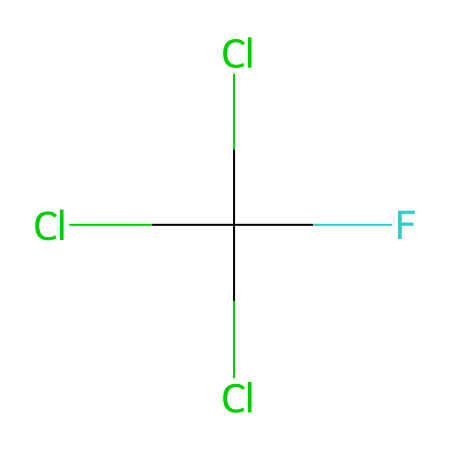What is the total number of halogen atoms in this molecule? The chemical structure shows three chlorine atoms (Cl) and one fluorine atom (F), making a total of four halogen atoms present in this compound.
Answer: four How many carbon atoms are in this chemical? The SMILES representation indicates there is only one carbon atom (C) in the molecular structure.
Answer: one Is this compound a liquid or a gas at room temperature? Chlorofluorocarbons (CFCs) are typically gaseous or liquid under standard conditions, but most are gases. This structure indicates it behaves as a refrigerant, thus it is likely a gas.
Answer: gas Identify the main uses of this molecule type. CFCs are historically used as refrigerants and propellants in aerosol sprays, so the main uses involve cooling applications and aerosol creation.
Answer: refrigerant What type of chemical reaction does this compound typically undergo? CFCs generally undergo chlorination or photodegradation reactions, where they break down in the presence of sunlight, leading to various products.
Answer: photodegradation How many bonds does the carbon atom form in this compound? The carbon atom is surrounded by three chlorine atoms and one fluorine atom, forming four single bonds with these atoms. Therefore, it has four bonds.
Answer: four What environmental concern is associated with this chemical? CFCs are known to contribute to ozone depletion when they break down in the stratosphere releasing chlorine atoms that react with ozone (O3).
Answer: ozone depletion 